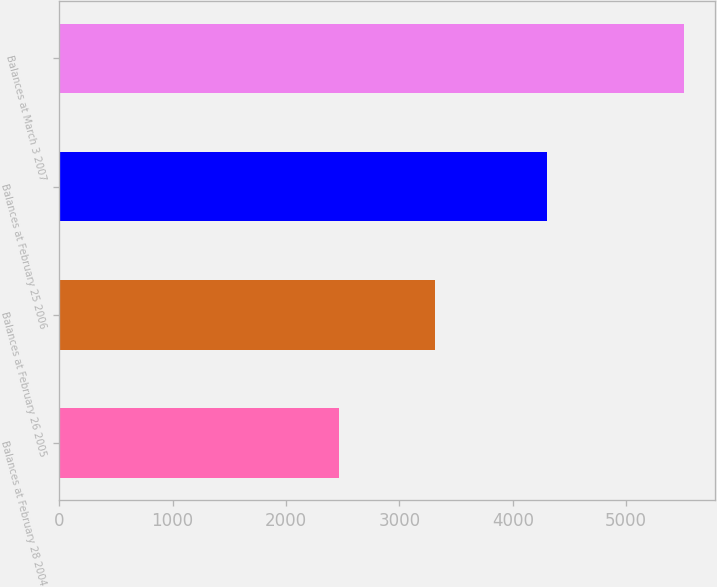<chart> <loc_0><loc_0><loc_500><loc_500><bar_chart><fcel>Balances at February 28 2004<fcel>Balances at February 26 2005<fcel>Balances at February 25 2006<fcel>Balances at March 3 2007<nl><fcel>2468<fcel>3315<fcel>4304<fcel>5507<nl></chart> 